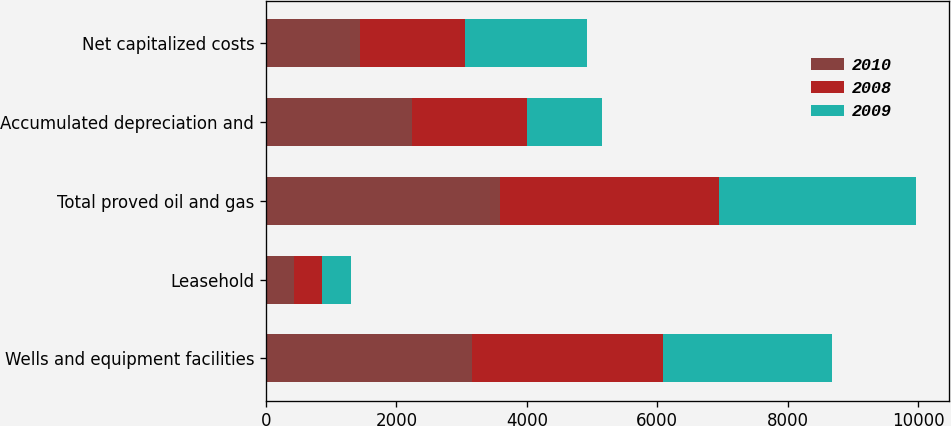Convert chart. <chart><loc_0><loc_0><loc_500><loc_500><stacked_bar_chart><ecel><fcel>Wells and equipment facilities<fcel>Leasehold<fcel>Total proved oil and gas<fcel>Accumulated depreciation and<fcel>Net capitalized costs<nl><fcel>2010<fcel>3158.8<fcel>433.1<fcel>3591.9<fcel>2235.4<fcel>1444.8<nl><fcel>2008<fcel>2920.7<fcel>433.5<fcel>3354.2<fcel>1764<fcel>1600.4<nl><fcel>2009<fcel>2595.4<fcel>429.8<fcel>3025.2<fcel>1155.6<fcel>1869.6<nl></chart> 